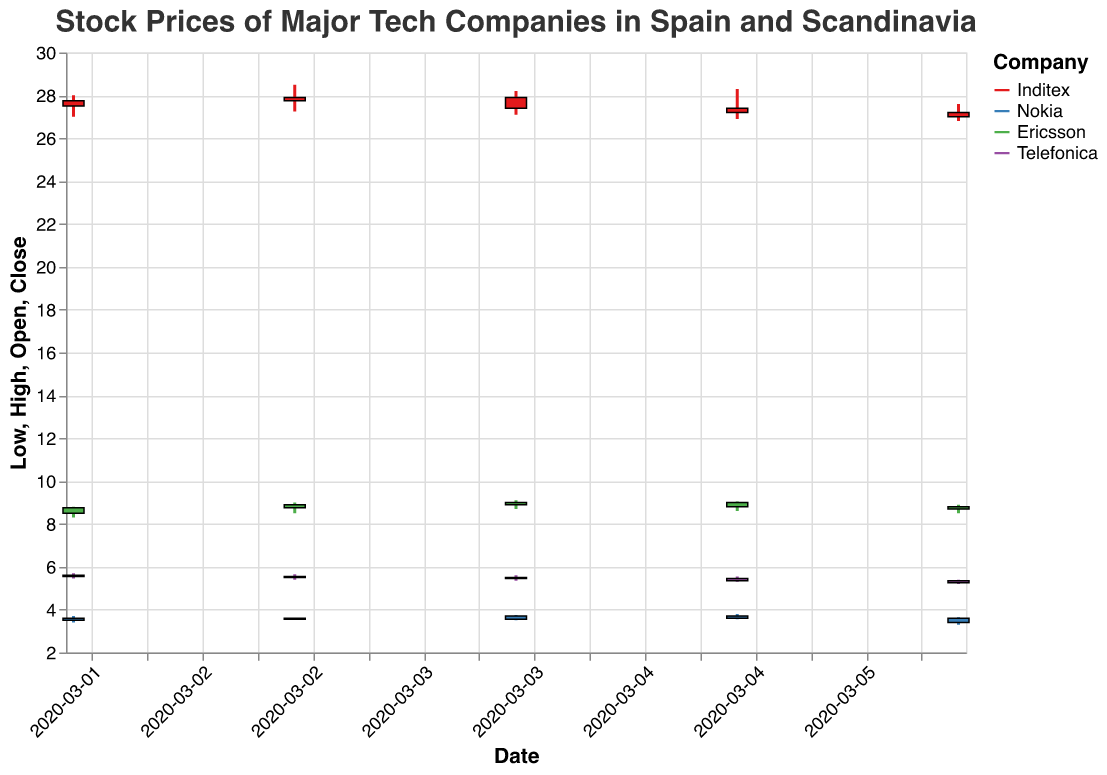What is the maximum closing price of Inditex during the given period? To find the maximum closing price of Inditex, look at the closing prices listed for each date and identify the highest value. From the data provided, the highest closing price for Inditex is on 2020-03-03 with a closing price of 27.90.
Answer: 27.90 Which company had the most distinct change in closing prices within the given period? To determine which company had the most distinct change in closing prices, calculate the range (difference between the highest and lowest closing prices) for each company. Inditex's range is 27.90 - 27.00 = 0.90, Nokia's range is 3.70 - 3.40 = 0.30, Ericsson's range is 9.00 - 8.70 = 0.30, and Telefonica's range is 5.55 - 5.25 = 0.30. Inditex had the largest range.
Answer: Inditex What was the closing price of Telefonica on March 6, 2020? Refer to the closing price data for Telefonica on March 6, 2020. The closing price is listed as 5.25.
Answer: 5.25 Which Scandinavian company had the highest opening price on March 4, 2020? Look at the opening prices of the Scandinavian companies (Nokia and Ericsson) on March 4, 2020. Ericsson had an opening price of 8.90 while Nokia had 3.55. Ericsson had the higher opening price.
Answer: Ericsson What is the average closing price of Nokia during the given period? Calculate the average closing price for Nokia by summing the closing prices (3.60 + 3.55 + 3.70 + 3.60 + 3.40) and dividing by the number of days (5). The total sum is 17.85, and the average is 17.85/5 = 3.57.
Answer: 3.57 Did any company have a higher stock price on March 5, 2020, compared to its opening price? Examine the closing and opening prices of each company on March 5, 2020. None of the companies (Inditex, Nokia, Ericsson, or Telefonica) have a closing price that exceeded their opening price on that date.
Answer: No How did the closing price of Ericsson change from March 2, 2020, to March 6, 2020? Compare the closing prices of Ericsson on March 2 (8.75) and March 6 (8.70). The price decreased by 0.05.
Answer: Decreased by 0.05 What was the lowest closing price recorded among all the companies during this period? Identify the minimum closing price among all the companies in the dataset. The lowest closing price is 3.40, recorded by Nokia on March 6, 2020.
Answer: 3.40 